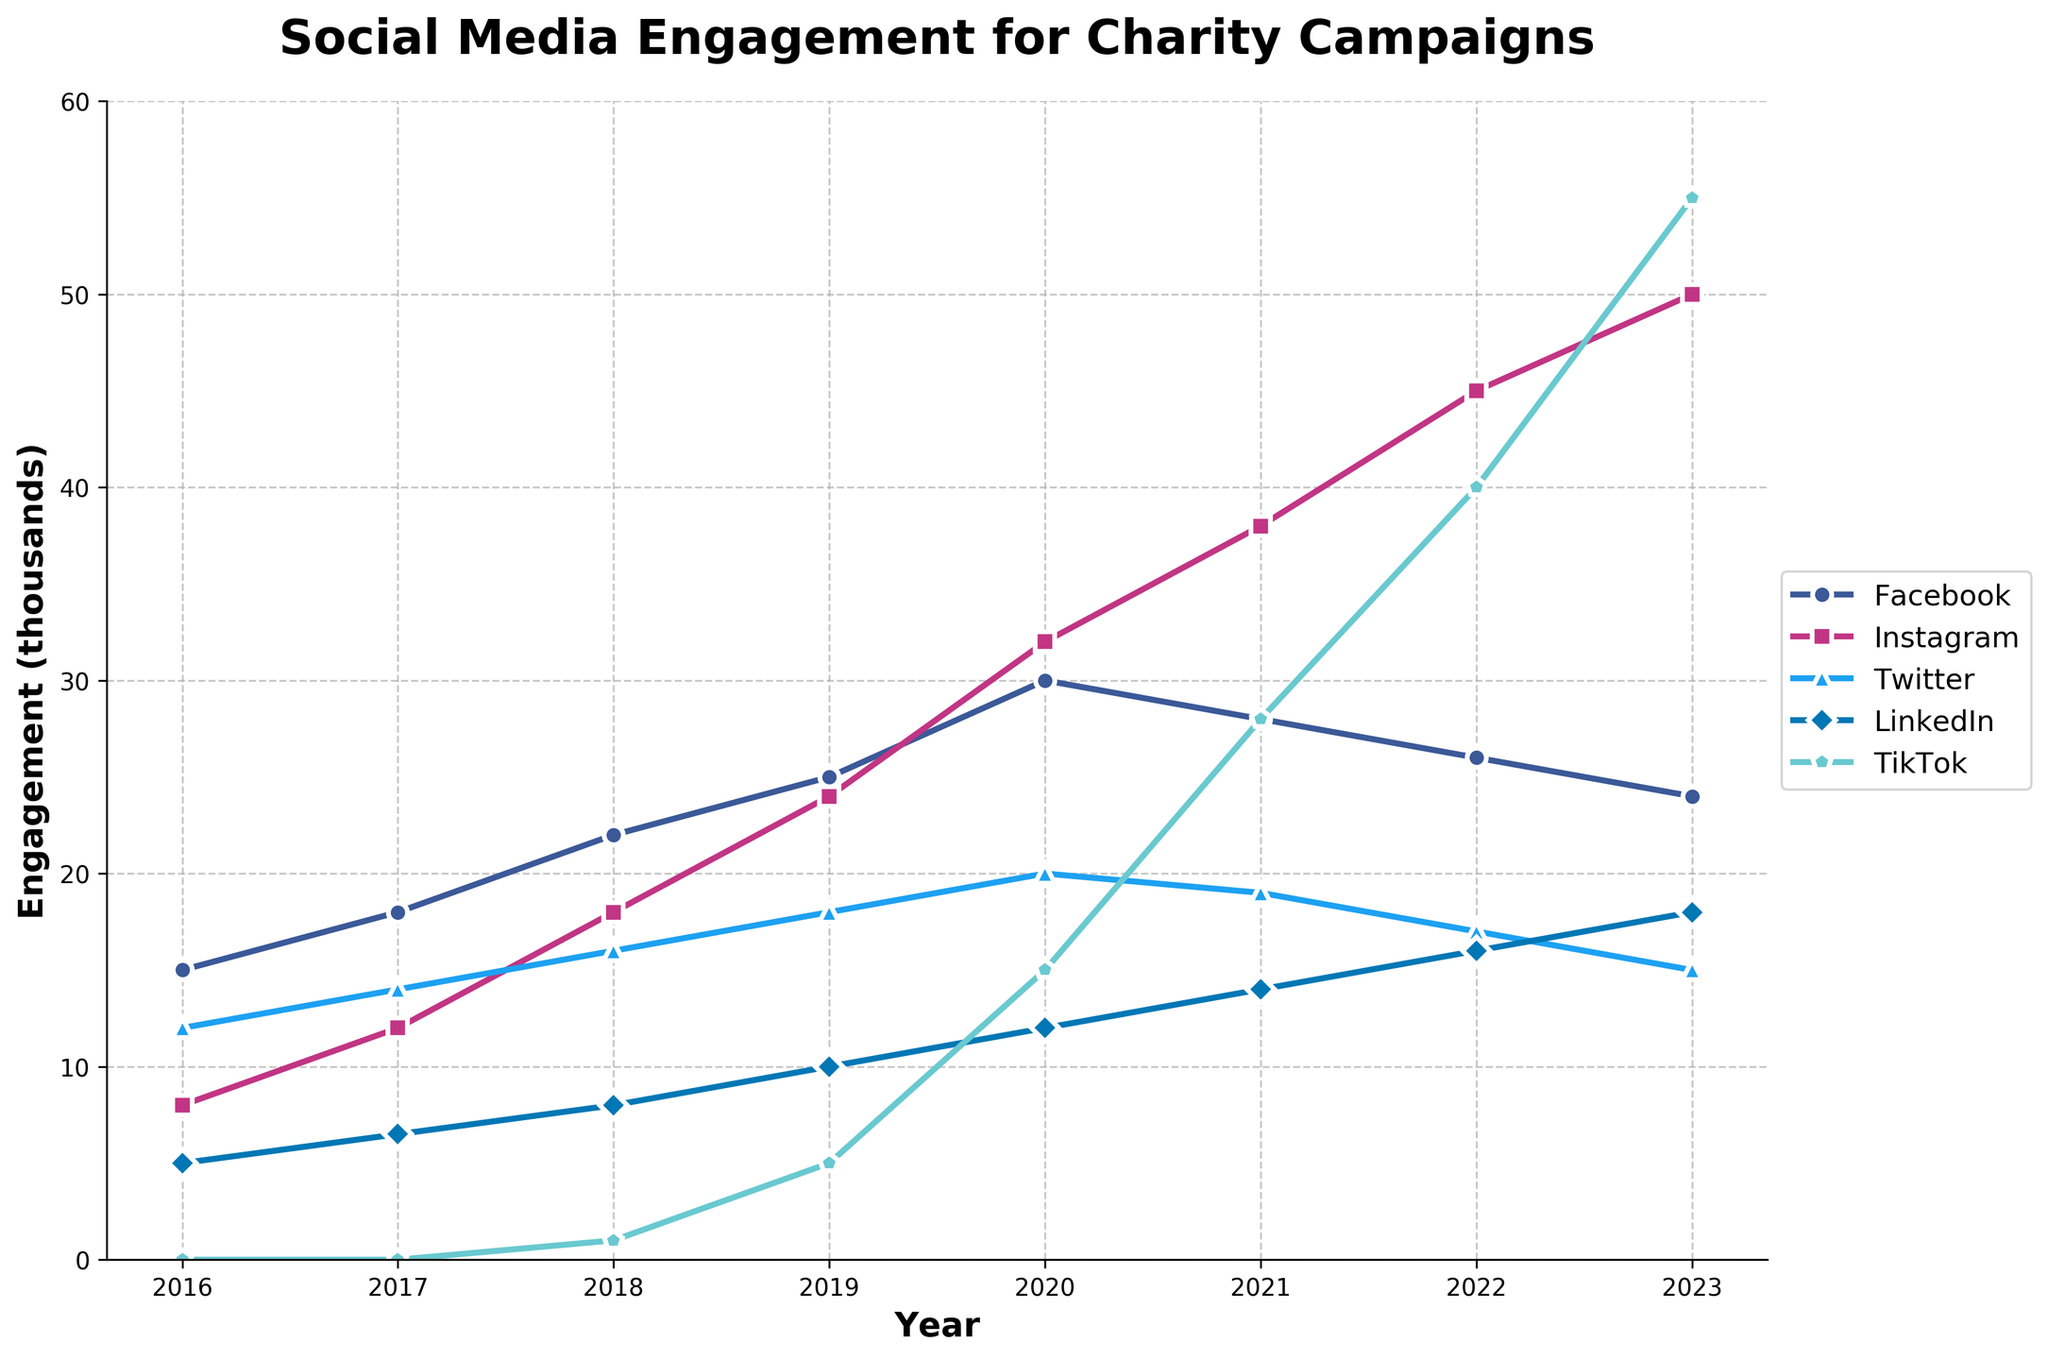Which platform showed the highest engagement in 2023? Look at the data points for all platforms in 2023; TikTok has the highest value at 55000.
Answer: TikTok How did Instagram's engagement change from 2016 to 2023? In 2016, Instagram's engagement was 8000, and in 2023 it improved to 50000. Calculate the difference, 50000 - 8000 = 42000.
Answer: Increased by 42000 Which platform had the lowest engagement in 2020? Refer to 2020 data points for each platform; Twitter had the lowest engagement at 20000.
Answer: Twitter By how much did Facebook's engagement decrease from 2020 to 2023? Facebook's engagement in 2020 was 30000, and in 2023 it was 24000. Calculate the difference, 30000 - 24000 = 6000.
Answer: Decreased by 6000 Compare the engagement trends of LinkedIn and TikTok from 2019 to 2023. Which had a larger increase? LinkedIn: (2019, 10000) to (2023, 18000); Increase = 18000 - 10000 = 8000. TikTok: (2019, 5000) to (2023, 55000); Increase = 55000 - 5000 = 50000. TikTok had a larger increase.
Answer: TikTok What is the total engagement for Instagram across all years? Sum values: 8000 + 12000 + 18000 + 24000 + 32000 + 38000 + 45000 + 50000 = 276000.
Answer: 276000 What trend can be observed in Twitter's engagement from 2016 to 2023? Twitter's engagement increased from 12000 in 2016 to a peak of 20000 in 2020 and then steadily decreased to 15000 by 2023.
Answer: Increase till 2020, then decrease Which year showed a significant rise in TikTok's engagement compared to previous years? TikTok had 15000 in 2020, rising to 28000 in 2021. Compare these two values, 28000 - 15000 = 13000, which is a significant increase compared to other years.
Answer: 2021 How did the total engagement for all platforms combined change from 2017 to 2023? Calculate total engagement for all platforms in 2017: 18000 + 12000 + 14000 + 6500 + 0 = 50500. For 2023: 24000 + 50000 + 15000 + 18000 + 55000 = 162000. Difference = 162000 - 50500 = 111500.
Answer: Increased by 111500 In which year did LinkedIn surpass Twitter in engagement for the first time? Compare the annual values; in 2021 LinkedIn (14000) surpasses Twitter (19000).
Answer: 2021 